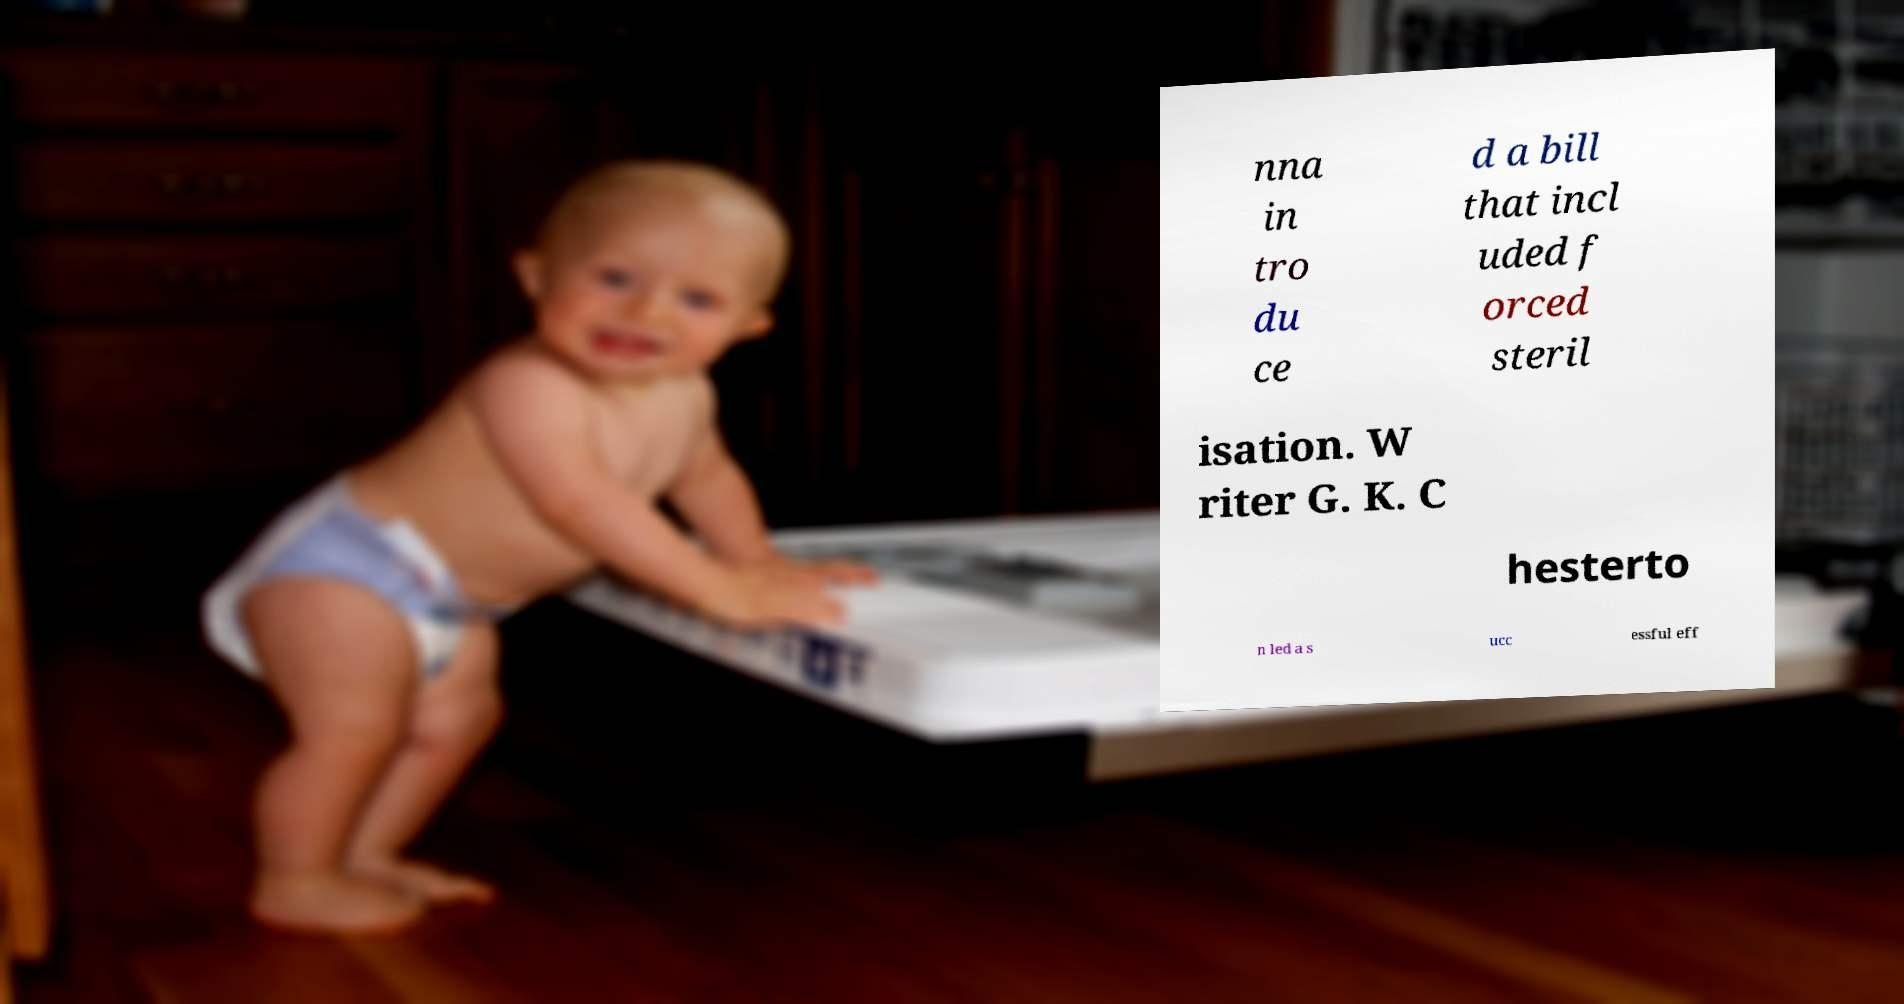For documentation purposes, I need the text within this image transcribed. Could you provide that? nna in tro du ce d a bill that incl uded f orced steril isation. W riter G. K. C hesterto n led a s ucc essful eff 